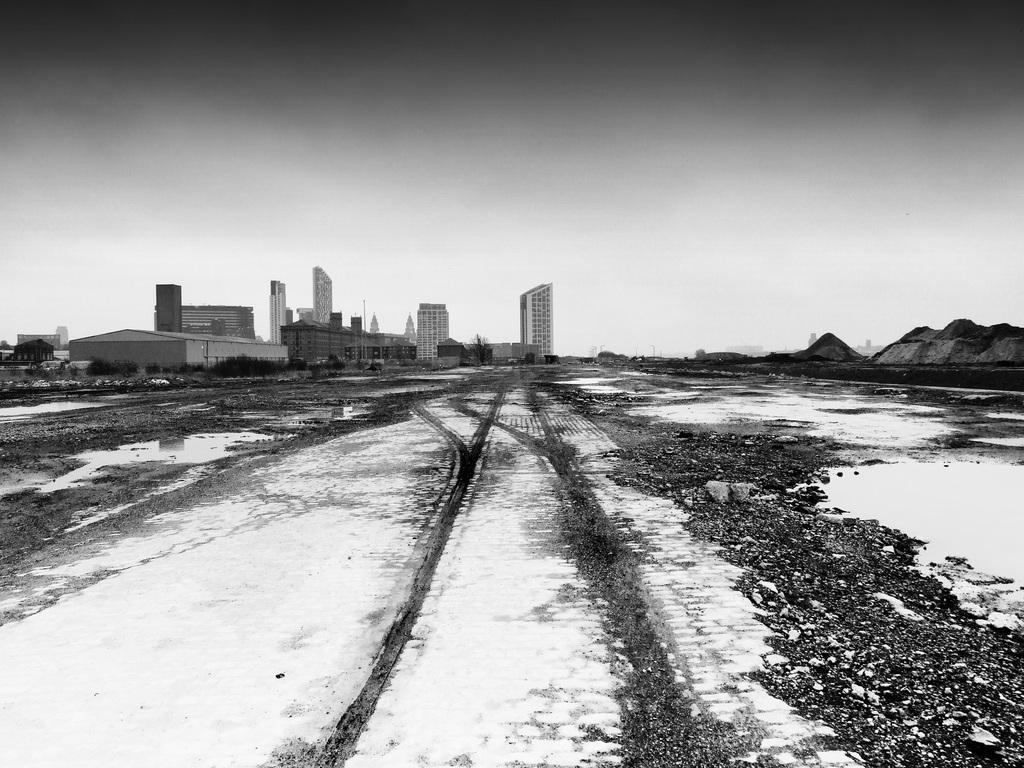How would you summarize this image in a sentence or two? This is a black and white image where we can see a land at the bottom of this image, and buildings in the background, and there is a sky at the top of this image. 